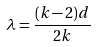<formula> <loc_0><loc_0><loc_500><loc_500>\lambda = \frac { ( k - 2 ) d } { 2 k }</formula> 